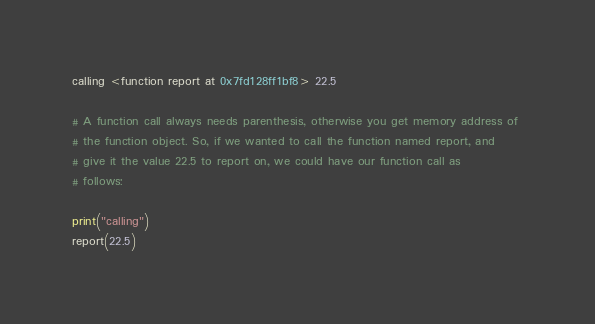Convert code to text. <code><loc_0><loc_0><loc_500><loc_500><_Python_>calling <function report at 0x7fd128ff1bf8> 22.5

# A function call always needs parenthesis, otherwise you get memory address of 
# the function object. So, if we wanted to call the function named report, and 
# give it the value 22.5 to report on, we could have our function call as 
# follows:

print("calling")
report(22.5)</code> 